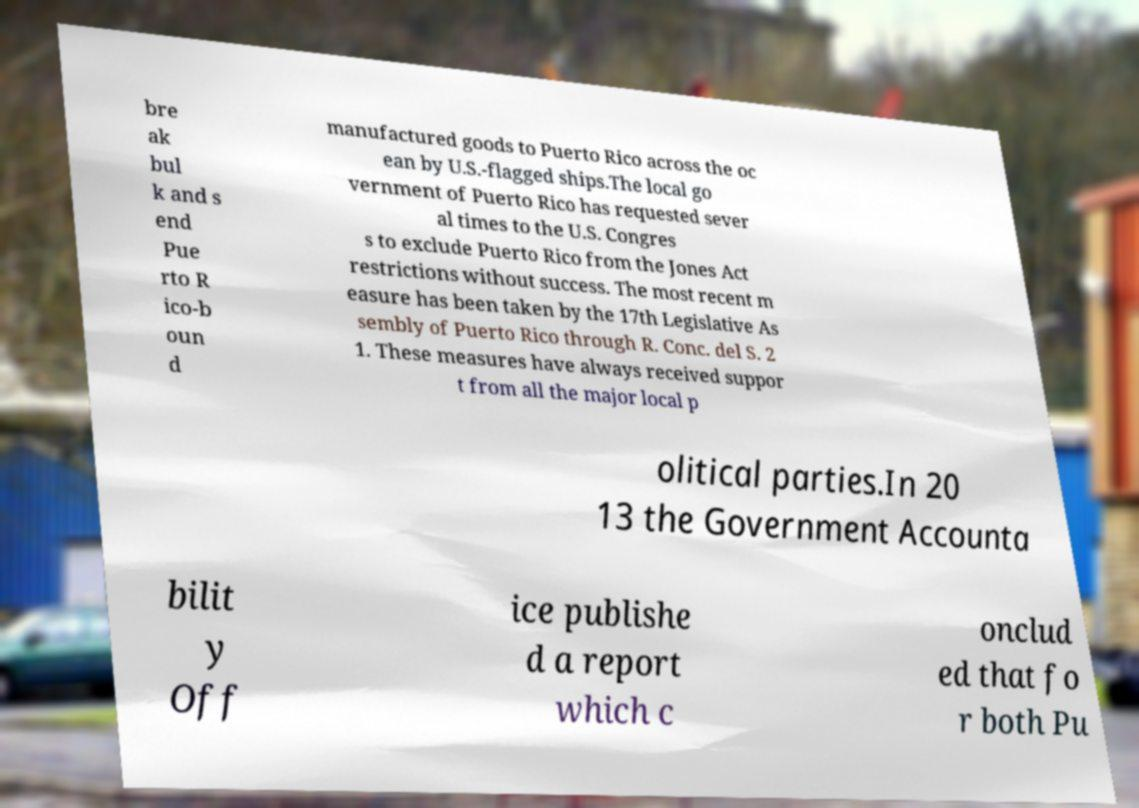For documentation purposes, I need the text within this image transcribed. Could you provide that? bre ak bul k and s end Pue rto R ico-b oun d manufactured goods to Puerto Rico across the oc ean by U.S.-flagged ships.The local go vernment of Puerto Rico has requested sever al times to the U.S. Congres s to exclude Puerto Rico from the Jones Act restrictions without success. The most recent m easure has been taken by the 17th Legislative As sembly of Puerto Rico through R. Conc. del S. 2 1. These measures have always received suppor t from all the major local p olitical parties.In 20 13 the Government Accounta bilit y Off ice publishe d a report which c onclud ed that fo r both Pu 